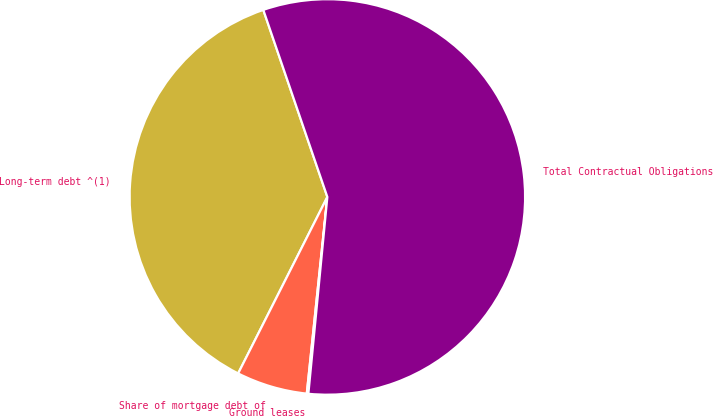Convert chart. <chart><loc_0><loc_0><loc_500><loc_500><pie_chart><fcel>Long-term debt ^(1)<fcel>Share of mortgage debt of<fcel>Ground leases<fcel>Total Contractual Obligations<nl><fcel>37.3%<fcel>5.79%<fcel>0.13%<fcel>56.78%<nl></chart> 